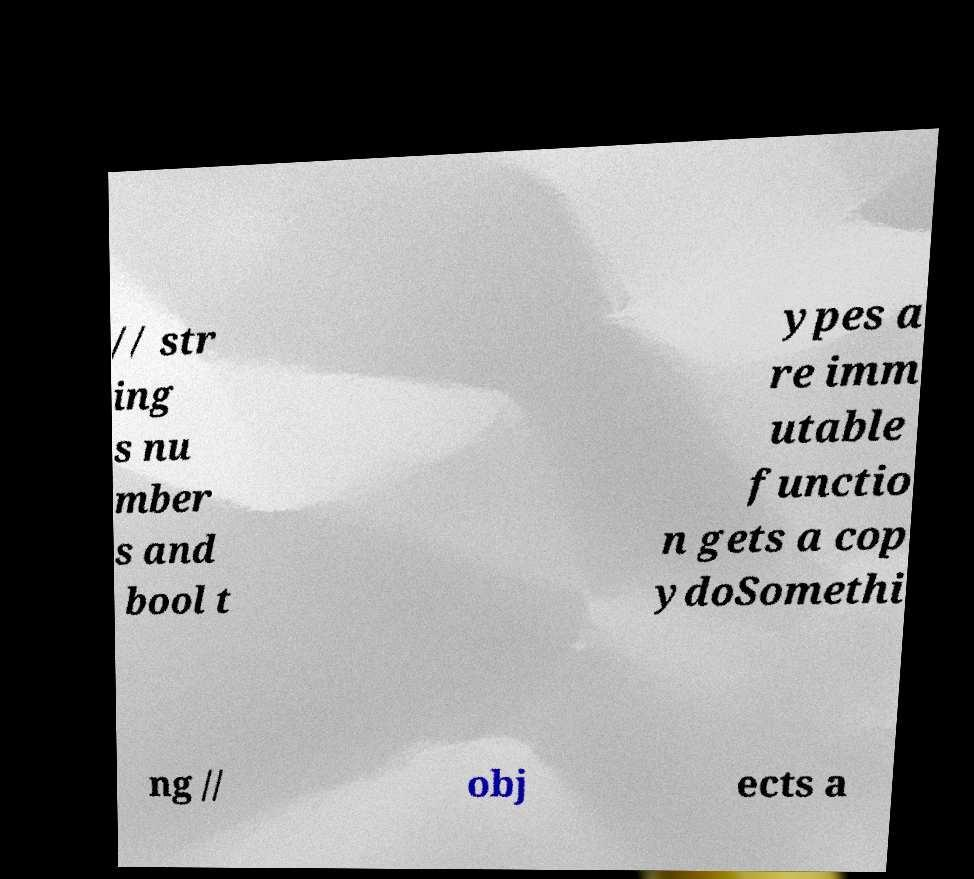Could you assist in decoding the text presented in this image and type it out clearly? // str ing s nu mber s and bool t ypes a re imm utable functio n gets a cop ydoSomethi ng // obj ects a 